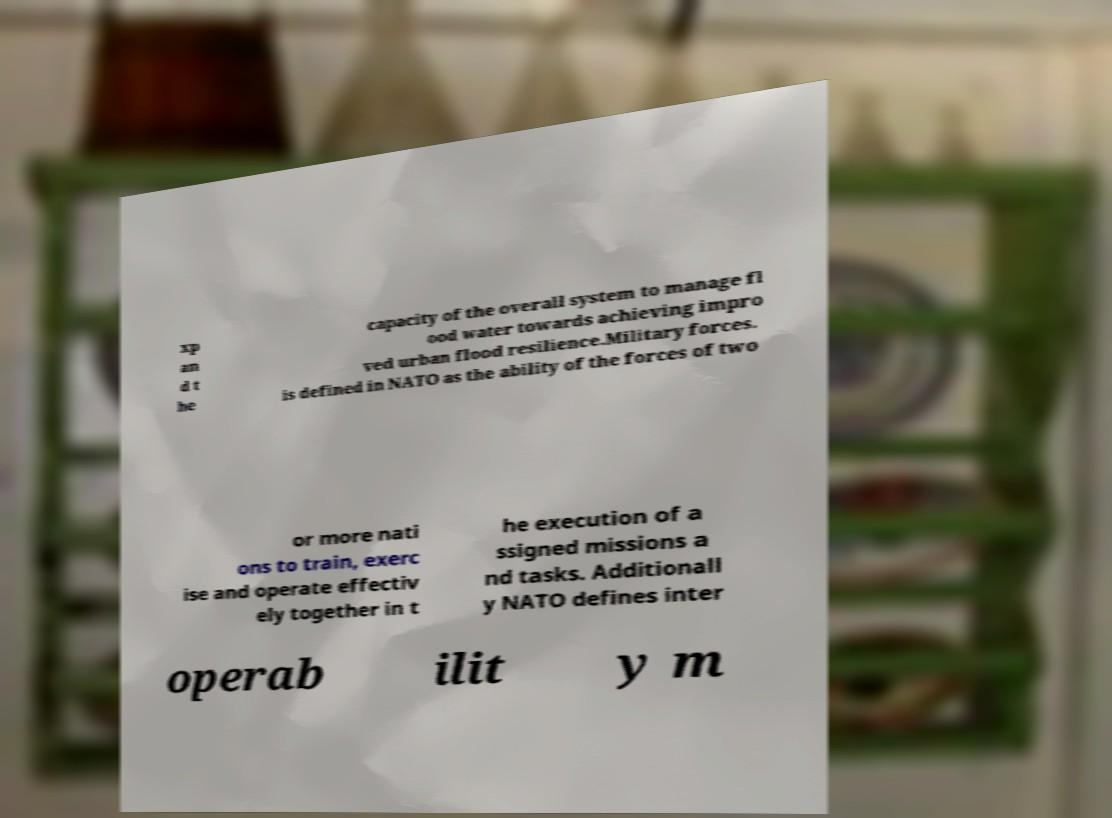Please identify and transcribe the text found in this image. xp an d t he capacity of the overall system to manage fl ood water towards achieving impro ved urban flood resilience.Military forces. is defined in NATO as the ability of the forces of two or more nati ons to train, exerc ise and operate effectiv ely together in t he execution of a ssigned missions a nd tasks. Additionall y NATO defines inter operab ilit y m 